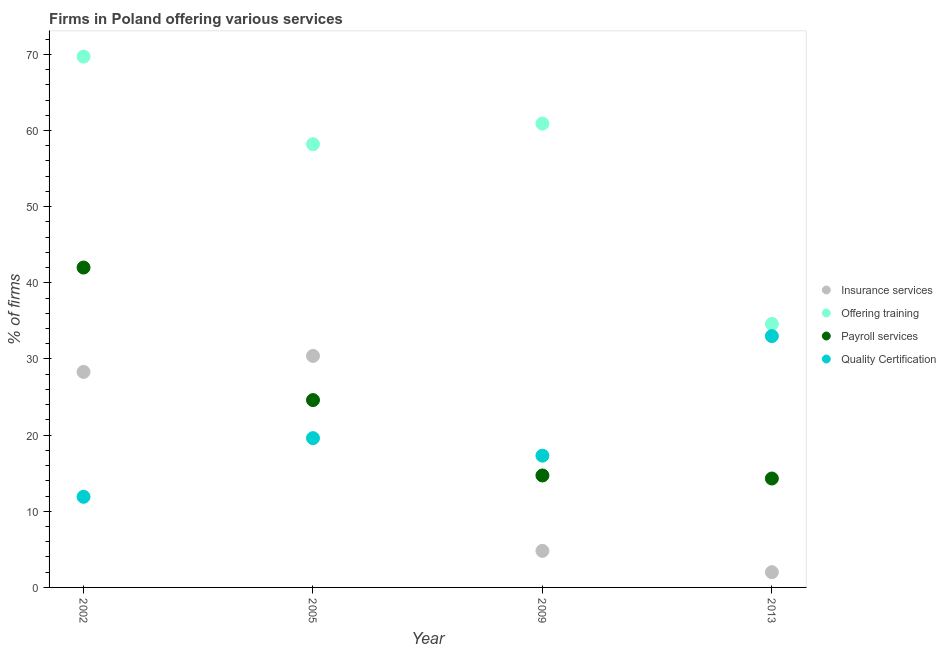Is the number of dotlines equal to the number of legend labels?
Your response must be concise. Yes. What is the percentage of firms offering payroll services in 2002?
Keep it short and to the point. 42. Across all years, what is the maximum percentage of firms offering payroll services?
Give a very brief answer. 42. Across all years, what is the minimum percentage of firms offering payroll services?
Your response must be concise. 14.3. In which year was the percentage of firms offering payroll services maximum?
Provide a succinct answer. 2002. What is the total percentage of firms offering quality certification in the graph?
Provide a succinct answer. 81.8. What is the difference between the percentage of firms offering payroll services in 2002 and that in 2013?
Keep it short and to the point. 27.7. What is the average percentage of firms offering training per year?
Offer a very short reply. 55.85. In the year 2005, what is the difference between the percentage of firms offering quality certification and percentage of firms offering payroll services?
Offer a very short reply. -5. In how many years, is the percentage of firms offering training greater than 2 %?
Offer a very short reply. 4. What is the ratio of the percentage of firms offering insurance services in 2002 to that in 2005?
Ensure brevity in your answer.  0.93. What is the difference between the highest and the second highest percentage of firms offering quality certification?
Offer a terse response. 13.4. What is the difference between the highest and the lowest percentage of firms offering quality certification?
Your answer should be compact. 21.1. In how many years, is the percentage of firms offering insurance services greater than the average percentage of firms offering insurance services taken over all years?
Give a very brief answer. 2. Is the sum of the percentage of firms offering insurance services in 2002 and 2013 greater than the maximum percentage of firms offering quality certification across all years?
Provide a short and direct response. No. Is it the case that in every year, the sum of the percentage of firms offering insurance services and percentage of firms offering training is greater than the percentage of firms offering payroll services?
Offer a terse response. Yes. Is the percentage of firms offering payroll services strictly greater than the percentage of firms offering insurance services over the years?
Offer a very short reply. No. Is the percentage of firms offering training strictly less than the percentage of firms offering quality certification over the years?
Your response must be concise. No. Does the graph contain grids?
Offer a terse response. No. Where does the legend appear in the graph?
Your answer should be very brief. Center right. What is the title of the graph?
Make the answer very short. Firms in Poland offering various services . What is the label or title of the X-axis?
Give a very brief answer. Year. What is the label or title of the Y-axis?
Make the answer very short. % of firms. What is the % of firms in Insurance services in 2002?
Offer a terse response. 28.3. What is the % of firms in Offering training in 2002?
Provide a short and direct response. 69.7. What is the % of firms in Insurance services in 2005?
Provide a succinct answer. 30.4. What is the % of firms of Offering training in 2005?
Your answer should be compact. 58.2. What is the % of firms of Payroll services in 2005?
Keep it short and to the point. 24.6. What is the % of firms in Quality Certification in 2005?
Offer a terse response. 19.6. What is the % of firms in Offering training in 2009?
Keep it short and to the point. 60.9. What is the % of firms in Insurance services in 2013?
Provide a succinct answer. 2. What is the % of firms in Offering training in 2013?
Give a very brief answer. 34.6. Across all years, what is the maximum % of firms in Insurance services?
Ensure brevity in your answer.  30.4. Across all years, what is the maximum % of firms of Offering training?
Provide a short and direct response. 69.7. Across all years, what is the maximum % of firms of Payroll services?
Offer a very short reply. 42. Across all years, what is the minimum % of firms in Insurance services?
Give a very brief answer. 2. Across all years, what is the minimum % of firms in Offering training?
Offer a very short reply. 34.6. What is the total % of firms of Insurance services in the graph?
Provide a succinct answer. 65.5. What is the total % of firms in Offering training in the graph?
Your answer should be very brief. 223.4. What is the total % of firms of Payroll services in the graph?
Your answer should be compact. 95.6. What is the total % of firms in Quality Certification in the graph?
Your answer should be very brief. 81.8. What is the difference between the % of firms of Payroll services in 2002 and that in 2005?
Your response must be concise. 17.4. What is the difference between the % of firms in Quality Certification in 2002 and that in 2005?
Offer a terse response. -7.7. What is the difference between the % of firms in Insurance services in 2002 and that in 2009?
Offer a terse response. 23.5. What is the difference between the % of firms of Offering training in 2002 and that in 2009?
Make the answer very short. 8.8. What is the difference between the % of firms in Payroll services in 2002 and that in 2009?
Your response must be concise. 27.3. What is the difference between the % of firms in Quality Certification in 2002 and that in 2009?
Offer a very short reply. -5.4. What is the difference between the % of firms in Insurance services in 2002 and that in 2013?
Your answer should be compact. 26.3. What is the difference between the % of firms in Offering training in 2002 and that in 2013?
Give a very brief answer. 35.1. What is the difference between the % of firms in Payroll services in 2002 and that in 2013?
Your answer should be very brief. 27.7. What is the difference between the % of firms in Quality Certification in 2002 and that in 2013?
Offer a terse response. -21.1. What is the difference between the % of firms in Insurance services in 2005 and that in 2009?
Your response must be concise. 25.6. What is the difference between the % of firms in Quality Certification in 2005 and that in 2009?
Your answer should be compact. 2.3. What is the difference between the % of firms of Insurance services in 2005 and that in 2013?
Offer a terse response. 28.4. What is the difference between the % of firms of Offering training in 2005 and that in 2013?
Keep it short and to the point. 23.6. What is the difference between the % of firms in Quality Certification in 2005 and that in 2013?
Make the answer very short. -13.4. What is the difference between the % of firms in Offering training in 2009 and that in 2013?
Give a very brief answer. 26.3. What is the difference between the % of firms in Quality Certification in 2009 and that in 2013?
Give a very brief answer. -15.7. What is the difference between the % of firms in Insurance services in 2002 and the % of firms in Offering training in 2005?
Your answer should be very brief. -29.9. What is the difference between the % of firms of Insurance services in 2002 and the % of firms of Quality Certification in 2005?
Make the answer very short. 8.7. What is the difference between the % of firms of Offering training in 2002 and the % of firms of Payroll services in 2005?
Make the answer very short. 45.1. What is the difference between the % of firms of Offering training in 2002 and the % of firms of Quality Certification in 2005?
Your response must be concise. 50.1. What is the difference between the % of firms in Payroll services in 2002 and the % of firms in Quality Certification in 2005?
Provide a succinct answer. 22.4. What is the difference between the % of firms in Insurance services in 2002 and the % of firms in Offering training in 2009?
Your response must be concise. -32.6. What is the difference between the % of firms of Insurance services in 2002 and the % of firms of Payroll services in 2009?
Offer a very short reply. 13.6. What is the difference between the % of firms in Insurance services in 2002 and the % of firms in Quality Certification in 2009?
Offer a very short reply. 11. What is the difference between the % of firms in Offering training in 2002 and the % of firms in Payroll services in 2009?
Give a very brief answer. 55. What is the difference between the % of firms of Offering training in 2002 and the % of firms of Quality Certification in 2009?
Make the answer very short. 52.4. What is the difference between the % of firms in Payroll services in 2002 and the % of firms in Quality Certification in 2009?
Keep it short and to the point. 24.7. What is the difference between the % of firms in Insurance services in 2002 and the % of firms in Offering training in 2013?
Your response must be concise. -6.3. What is the difference between the % of firms in Insurance services in 2002 and the % of firms in Payroll services in 2013?
Ensure brevity in your answer.  14. What is the difference between the % of firms of Insurance services in 2002 and the % of firms of Quality Certification in 2013?
Ensure brevity in your answer.  -4.7. What is the difference between the % of firms in Offering training in 2002 and the % of firms in Payroll services in 2013?
Make the answer very short. 55.4. What is the difference between the % of firms of Offering training in 2002 and the % of firms of Quality Certification in 2013?
Your answer should be very brief. 36.7. What is the difference between the % of firms in Payroll services in 2002 and the % of firms in Quality Certification in 2013?
Your answer should be compact. 9. What is the difference between the % of firms in Insurance services in 2005 and the % of firms in Offering training in 2009?
Provide a succinct answer. -30.5. What is the difference between the % of firms in Insurance services in 2005 and the % of firms in Payroll services in 2009?
Provide a succinct answer. 15.7. What is the difference between the % of firms of Offering training in 2005 and the % of firms of Payroll services in 2009?
Your response must be concise. 43.5. What is the difference between the % of firms of Offering training in 2005 and the % of firms of Quality Certification in 2009?
Keep it short and to the point. 40.9. What is the difference between the % of firms in Insurance services in 2005 and the % of firms in Payroll services in 2013?
Your response must be concise. 16.1. What is the difference between the % of firms in Offering training in 2005 and the % of firms in Payroll services in 2013?
Provide a short and direct response. 43.9. What is the difference between the % of firms in Offering training in 2005 and the % of firms in Quality Certification in 2013?
Give a very brief answer. 25.2. What is the difference between the % of firms in Insurance services in 2009 and the % of firms in Offering training in 2013?
Give a very brief answer. -29.8. What is the difference between the % of firms of Insurance services in 2009 and the % of firms of Quality Certification in 2013?
Your response must be concise. -28.2. What is the difference between the % of firms in Offering training in 2009 and the % of firms in Payroll services in 2013?
Your answer should be compact. 46.6. What is the difference between the % of firms in Offering training in 2009 and the % of firms in Quality Certification in 2013?
Provide a short and direct response. 27.9. What is the difference between the % of firms of Payroll services in 2009 and the % of firms of Quality Certification in 2013?
Offer a terse response. -18.3. What is the average % of firms of Insurance services per year?
Offer a terse response. 16.38. What is the average % of firms in Offering training per year?
Offer a very short reply. 55.85. What is the average % of firms of Payroll services per year?
Make the answer very short. 23.9. What is the average % of firms in Quality Certification per year?
Provide a succinct answer. 20.45. In the year 2002, what is the difference between the % of firms of Insurance services and % of firms of Offering training?
Make the answer very short. -41.4. In the year 2002, what is the difference between the % of firms in Insurance services and % of firms in Payroll services?
Your answer should be very brief. -13.7. In the year 2002, what is the difference between the % of firms in Insurance services and % of firms in Quality Certification?
Offer a very short reply. 16.4. In the year 2002, what is the difference between the % of firms of Offering training and % of firms of Payroll services?
Offer a terse response. 27.7. In the year 2002, what is the difference between the % of firms in Offering training and % of firms in Quality Certification?
Provide a short and direct response. 57.8. In the year 2002, what is the difference between the % of firms of Payroll services and % of firms of Quality Certification?
Offer a very short reply. 30.1. In the year 2005, what is the difference between the % of firms in Insurance services and % of firms in Offering training?
Your answer should be very brief. -27.8. In the year 2005, what is the difference between the % of firms of Insurance services and % of firms of Payroll services?
Offer a very short reply. 5.8. In the year 2005, what is the difference between the % of firms of Insurance services and % of firms of Quality Certification?
Your answer should be very brief. 10.8. In the year 2005, what is the difference between the % of firms in Offering training and % of firms in Payroll services?
Your answer should be very brief. 33.6. In the year 2005, what is the difference between the % of firms in Offering training and % of firms in Quality Certification?
Your response must be concise. 38.6. In the year 2009, what is the difference between the % of firms of Insurance services and % of firms of Offering training?
Your answer should be very brief. -56.1. In the year 2009, what is the difference between the % of firms in Insurance services and % of firms in Payroll services?
Provide a short and direct response. -9.9. In the year 2009, what is the difference between the % of firms of Insurance services and % of firms of Quality Certification?
Offer a terse response. -12.5. In the year 2009, what is the difference between the % of firms of Offering training and % of firms of Payroll services?
Your response must be concise. 46.2. In the year 2009, what is the difference between the % of firms in Offering training and % of firms in Quality Certification?
Your answer should be very brief. 43.6. In the year 2013, what is the difference between the % of firms of Insurance services and % of firms of Offering training?
Make the answer very short. -32.6. In the year 2013, what is the difference between the % of firms in Insurance services and % of firms in Payroll services?
Provide a short and direct response. -12.3. In the year 2013, what is the difference between the % of firms of Insurance services and % of firms of Quality Certification?
Offer a very short reply. -31. In the year 2013, what is the difference between the % of firms of Offering training and % of firms of Payroll services?
Offer a very short reply. 20.3. In the year 2013, what is the difference between the % of firms in Offering training and % of firms in Quality Certification?
Keep it short and to the point. 1.6. In the year 2013, what is the difference between the % of firms of Payroll services and % of firms of Quality Certification?
Your answer should be very brief. -18.7. What is the ratio of the % of firms in Insurance services in 2002 to that in 2005?
Offer a very short reply. 0.93. What is the ratio of the % of firms of Offering training in 2002 to that in 2005?
Keep it short and to the point. 1.2. What is the ratio of the % of firms of Payroll services in 2002 to that in 2005?
Provide a succinct answer. 1.71. What is the ratio of the % of firms of Quality Certification in 2002 to that in 2005?
Offer a very short reply. 0.61. What is the ratio of the % of firms of Insurance services in 2002 to that in 2009?
Provide a short and direct response. 5.9. What is the ratio of the % of firms in Offering training in 2002 to that in 2009?
Provide a short and direct response. 1.14. What is the ratio of the % of firms of Payroll services in 2002 to that in 2009?
Your answer should be very brief. 2.86. What is the ratio of the % of firms in Quality Certification in 2002 to that in 2009?
Provide a short and direct response. 0.69. What is the ratio of the % of firms in Insurance services in 2002 to that in 2013?
Make the answer very short. 14.15. What is the ratio of the % of firms of Offering training in 2002 to that in 2013?
Ensure brevity in your answer.  2.01. What is the ratio of the % of firms in Payroll services in 2002 to that in 2013?
Offer a terse response. 2.94. What is the ratio of the % of firms in Quality Certification in 2002 to that in 2013?
Your answer should be compact. 0.36. What is the ratio of the % of firms in Insurance services in 2005 to that in 2009?
Offer a very short reply. 6.33. What is the ratio of the % of firms of Offering training in 2005 to that in 2009?
Your answer should be very brief. 0.96. What is the ratio of the % of firms of Payroll services in 2005 to that in 2009?
Your response must be concise. 1.67. What is the ratio of the % of firms of Quality Certification in 2005 to that in 2009?
Keep it short and to the point. 1.13. What is the ratio of the % of firms of Offering training in 2005 to that in 2013?
Offer a very short reply. 1.68. What is the ratio of the % of firms of Payroll services in 2005 to that in 2013?
Give a very brief answer. 1.72. What is the ratio of the % of firms of Quality Certification in 2005 to that in 2013?
Provide a succinct answer. 0.59. What is the ratio of the % of firms of Offering training in 2009 to that in 2013?
Your answer should be very brief. 1.76. What is the ratio of the % of firms in Payroll services in 2009 to that in 2013?
Your answer should be very brief. 1.03. What is the ratio of the % of firms of Quality Certification in 2009 to that in 2013?
Your answer should be very brief. 0.52. What is the difference between the highest and the second highest % of firms of Insurance services?
Offer a very short reply. 2.1. What is the difference between the highest and the second highest % of firms of Payroll services?
Keep it short and to the point. 17.4. What is the difference between the highest and the lowest % of firms of Insurance services?
Offer a terse response. 28.4. What is the difference between the highest and the lowest % of firms in Offering training?
Give a very brief answer. 35.1. What is the difference between the highest and the lowest % of firms in Payroll services?
Make the answer very short. 27.7. What is the difference between the highest and the lowest % of firms in Quality Certification?
Offer a terse response. 21.1. 